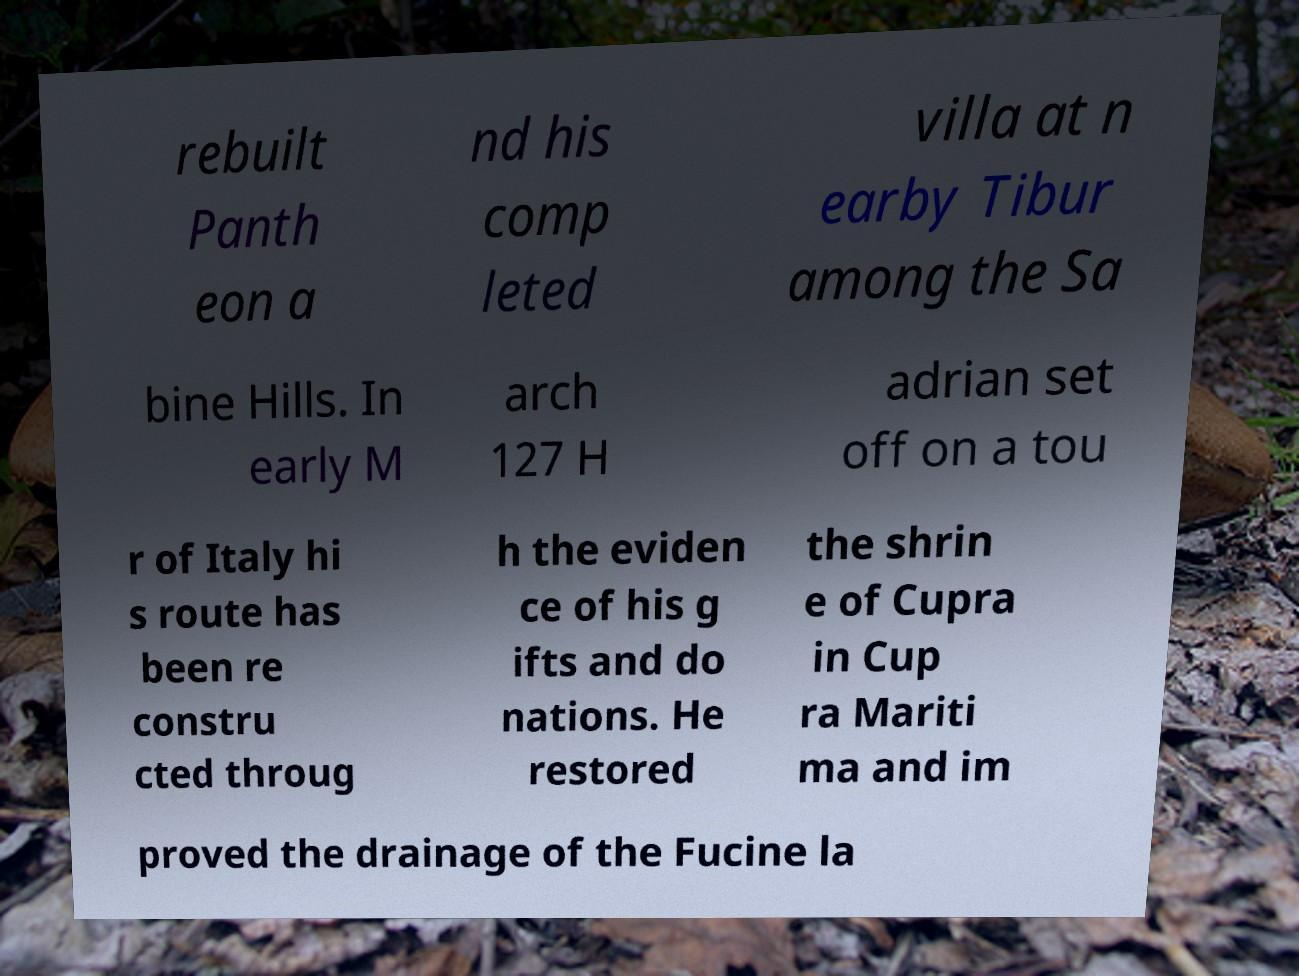What messages or text are displayed in this image? I need them in a readable, typed format. rebuilt Panth eon a nd his comp leted villa at n earby Tibur among the Sa bine Hills. In early M arch 127 H adrian set off on a tou r of Italy hi s route has been re constru cted throug h the eviden ce of his g ifts and do nations. He restored the shrin e of Cupra in Cup ra Mariti ma and im proved the drainage of the Fucine la 